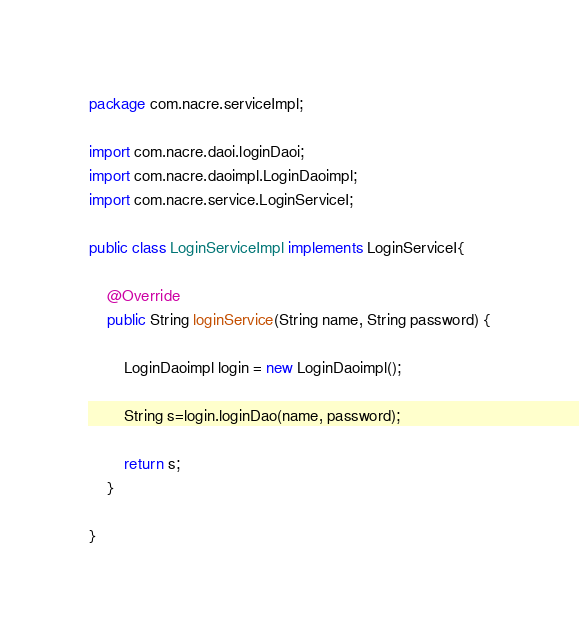<code> <loc_0><loc_0><loc_500><loc_500><_Java_>package com.nacre.serviceImpl;

import com.nacre.daoi.loginDaoi;
import com.nacre.daoimpl.LoginDaoimpl;
import com.nacre.service.LoginServiceI;

public class LoginServiceImpl implements LoginServiceI{

	@Override
	public String loginService(String name, String password) {
	
		LoginDaoimpl login = new LoginDaoimpl();
		
		String s=login.loginDao(name, password);
		
		return s;
	}

}
</code> 